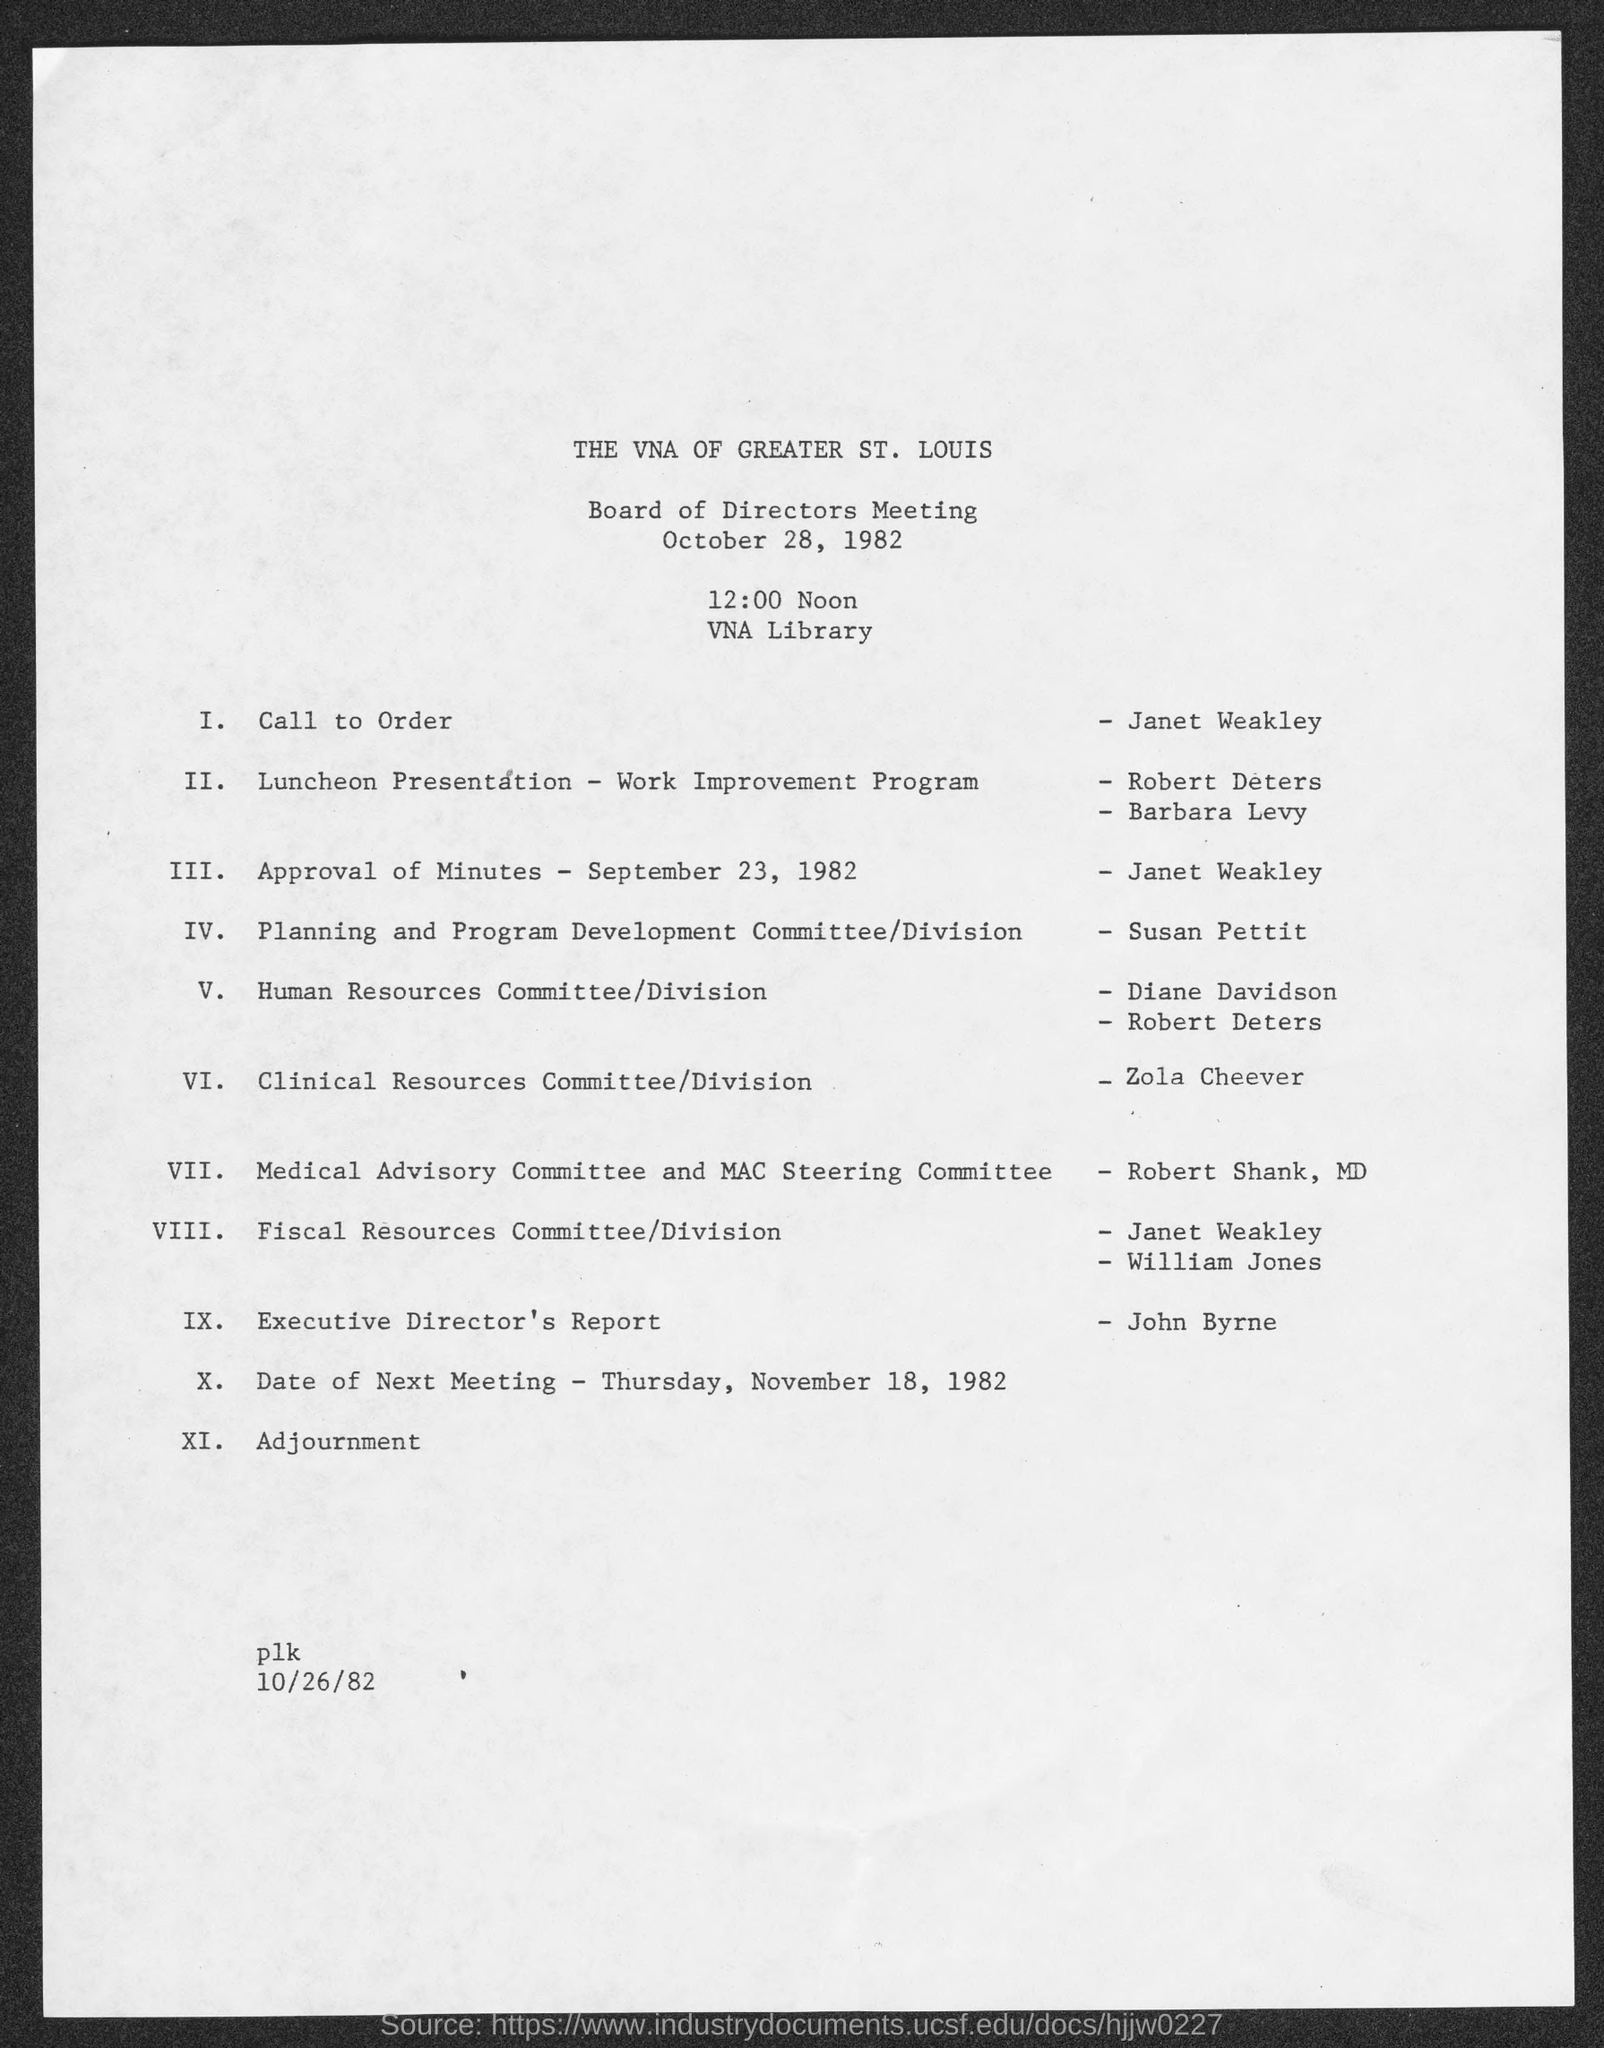What is the date of board of directors meeting ?
Ensure brevity in your answer.  October 28 ,1982. The executive directors report is given by whom ?
Provide a short and direct response. John Byrne. The call to order is given by
Your answer should be compact. Janet Weakley. What is the date for approval of minutes
Make the answer very short. September 23 . 1982. The clinical resources committee / Division is given by ?
Offer a very short reply. Zola Cheever. The approval of minutes - september 23 ,1982 is given by ?
Your response must be concise. Janet Weakley. What is the total no of events ?
Keep it short and to the point. XI. 